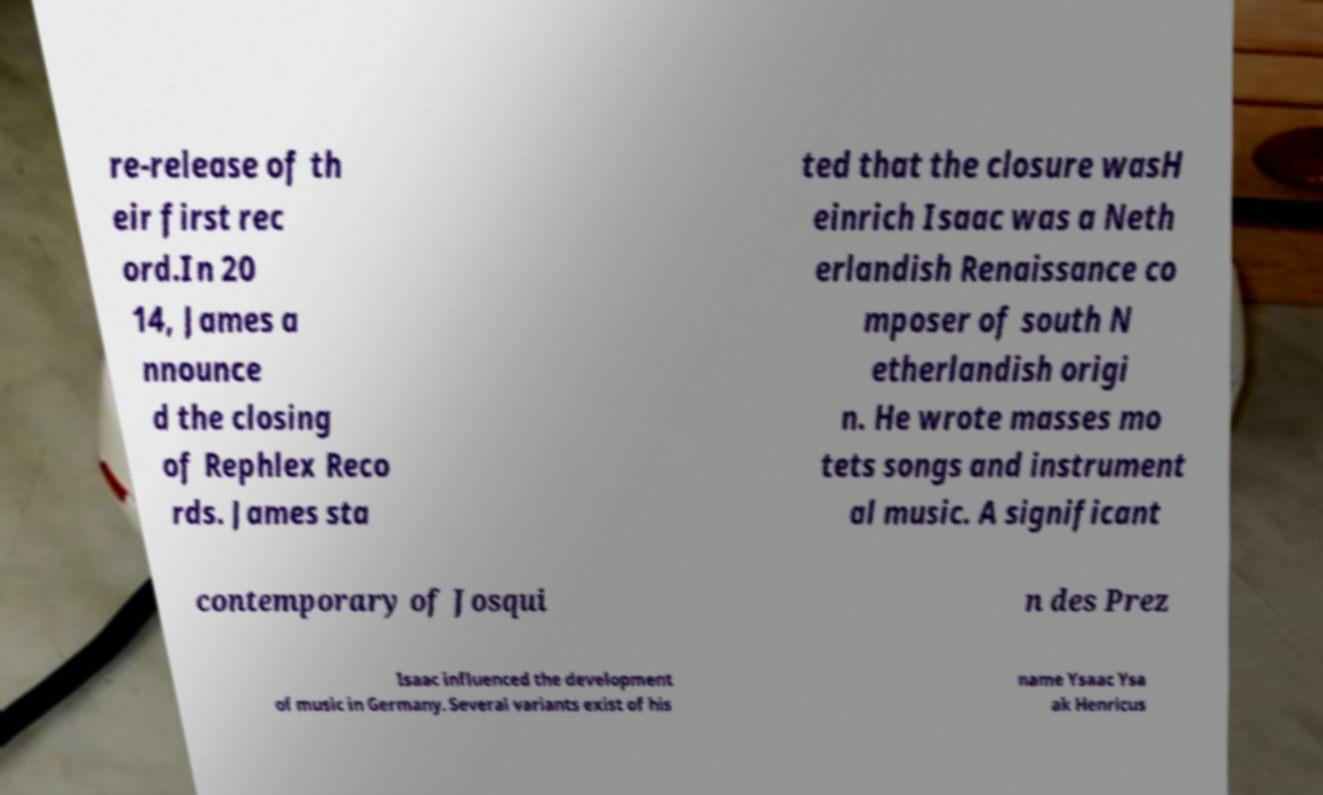Could you extract and type out the text from this image? re-release of th eir first rec ord.In 20 14, James a nnounce d the closing of Rephlex Reco rds. James sta ted that the closure wasH einrich Isaac was a Neth erlandish Renaissance co mposer of south N etherlandish origi n. He wrote masses mo tets songs and instrument al music. A significant contemporary of Josqui n des Prez Isaac influenced the development of music in Germany. Several variants exist of his name Ysaac Ysa ak Henricus 